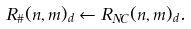Convert formula to latex. <formula><loc_0><loc_0><loc_500><loc_500>R _ { \# } ( n , m ) _ { d } \leftarrow R _ { N C } ( n , m ) _ { d } .</formula> 